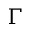<formula> <loc_0><loc_0><loc_500><loc_500>\Gamma</formula> 